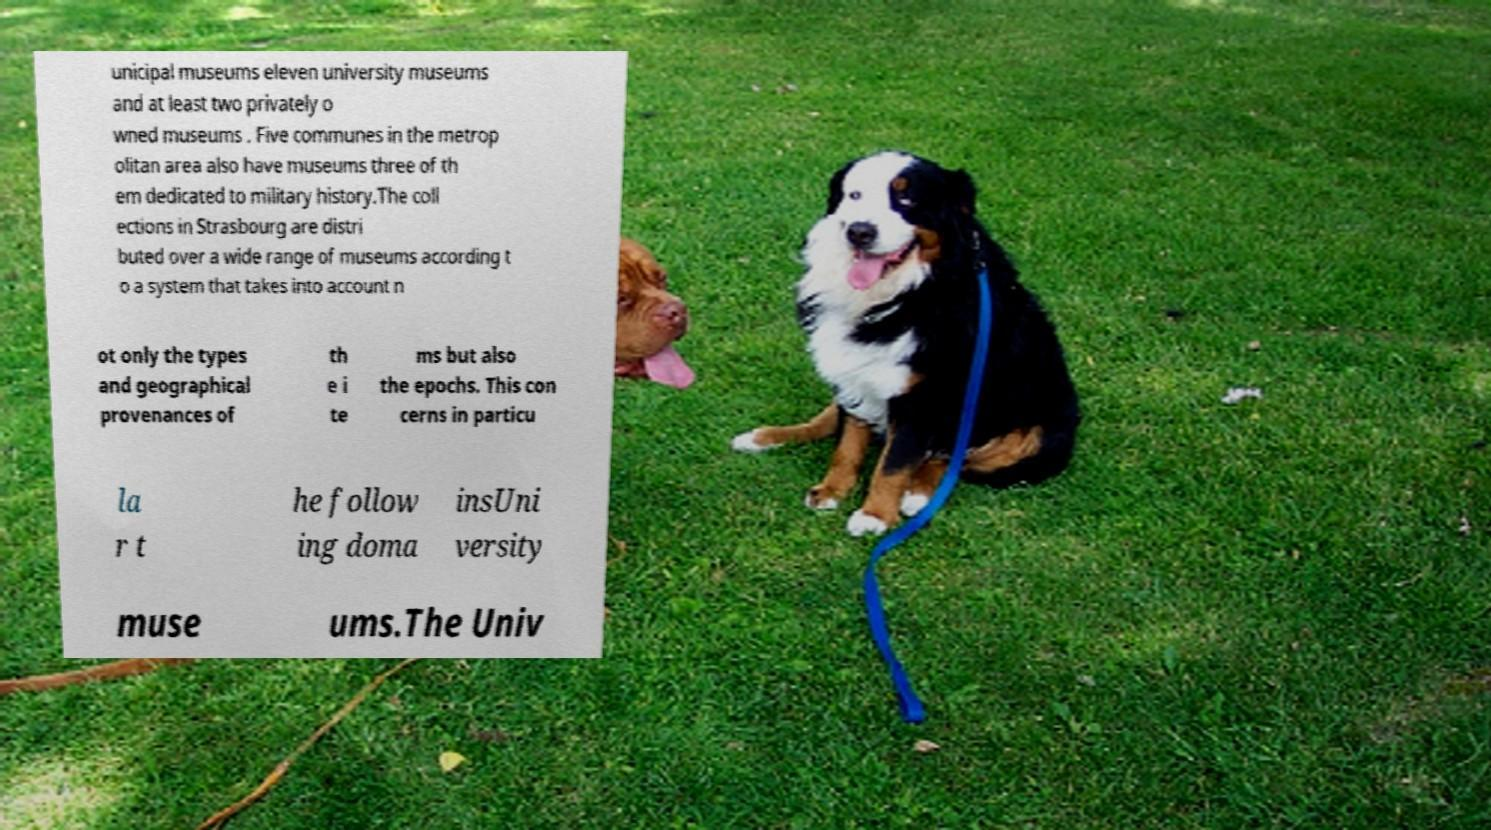I need the written content from this picture converted into text. Can you do that? unicipal museums eleven university museums and at least two privately o wned museums . Five communes in the metrop olitan area also have museums three of th em dedicated to military history.The coll ections in Strasbourg are distri buted over a wide range of museums according t o a system that takes into account n ot only the types and geographical provenances of th e i te ms but also the epochs. This con cerns in particu la r t he follow ing doma insUni versity muse ums.The Univ 